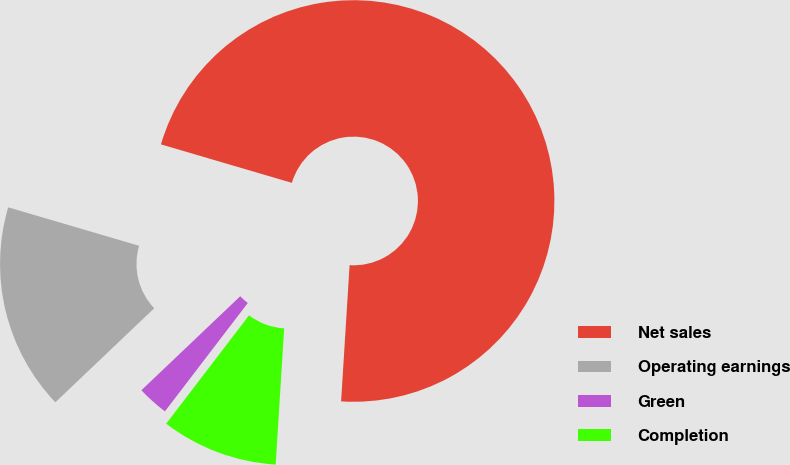<chart> <loc_0><loc_0><loc_500><loc_500><pie_chart><fcel>Net sales<fcel>Operating earnings<fcel>Green<fcel>Completion<nl><fcel>71.44%<fcel>16.65%<fcel>2.51%<fcel>9.4%<nl></chart> 